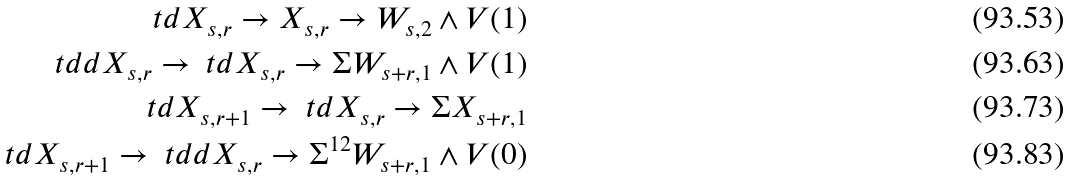Convert formula to latex. <formula><loc_0><loc_0><loc_500><loc_500>\ t d { X } _ { s , r } \rightarrow X _ { s , r } \rightarrow W _ { s , 2 } \wedge V ( 1 ) \\ \ t d d { X } _ { s , r } \rightarrow \ t d { X } _ { s , r } \rightarrow \Sigma W _ { s + r , 1 } \wedge V ( 1 ) \\ \ t d { X } _ { s , r + 1 } \rightarrow \ t d { X } _ { s , r } \rightarrow \Sigma X _ { s + r , 1 } \\ \ t d { X } _ { s , r + 1 } \rightarrow \ t d d { X } _ { s , r } \rightarrow \Sigma ^ { 1 2 } W _ { s + r , 1 } \wedge V ( 0 )</formula> 